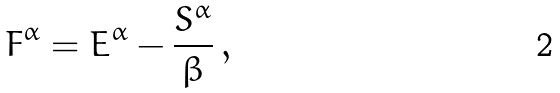Convert formula to latex. <formula><loc_0><loc_0><loc_500><loc_500>F ^ { \alpha } = E ^ { \alpha } - \frac { S ^ { \alpha } } { \beta } \, ,</formula> 